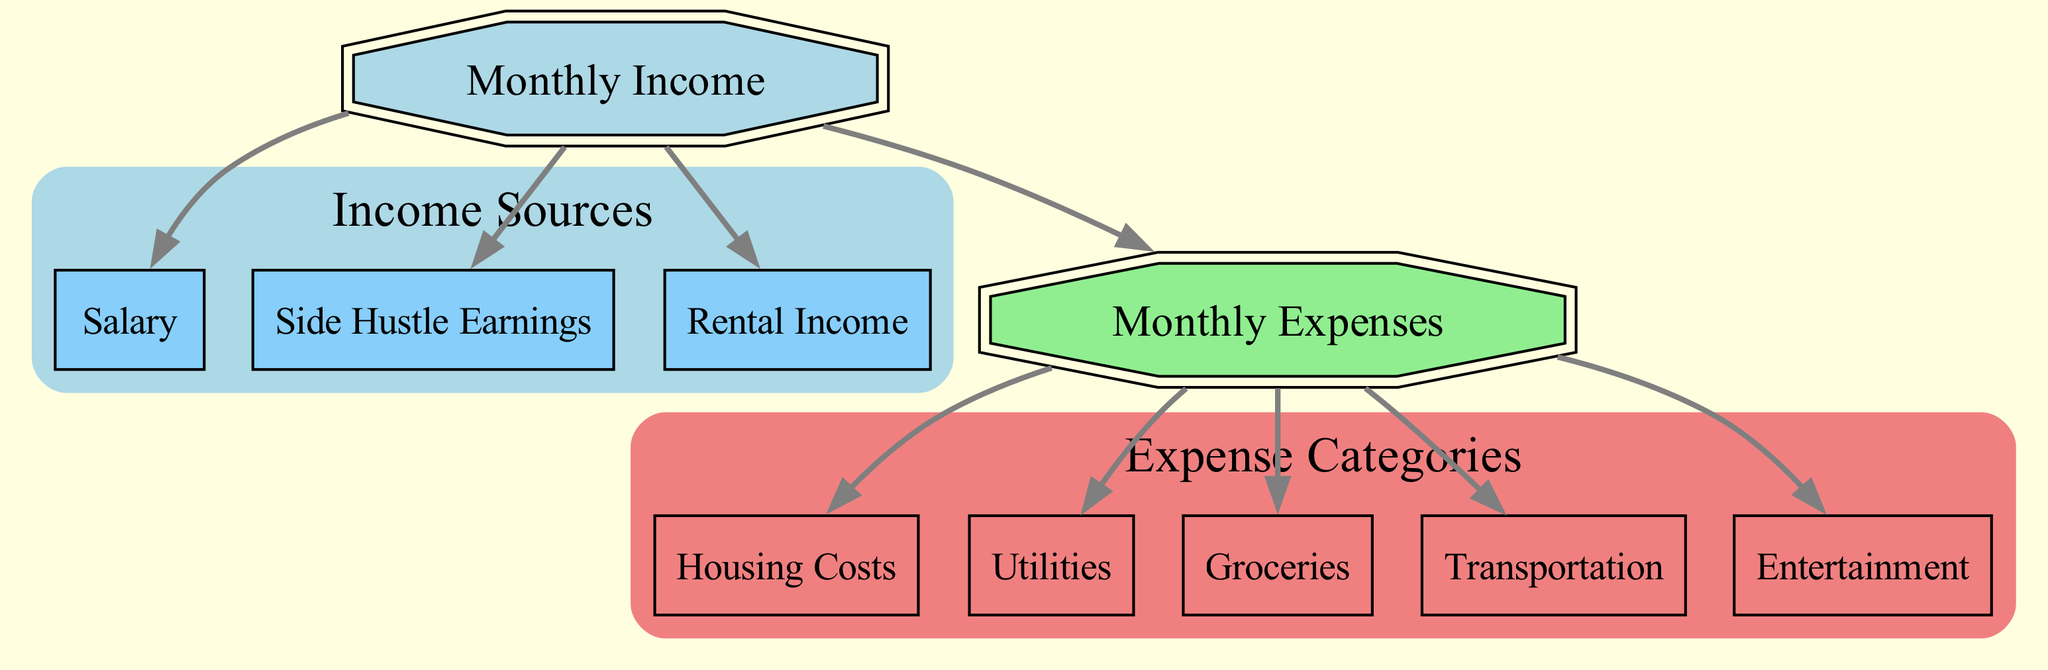What are the types of income sources in the diagram? The nodes labeled as Salary, Side Hustle Earnings, and Rental Income fall under the category of income sources in the diagram. These nodes are directly connected to the main Income node.
Answer: Salary, Side Hustle Earnings, Rental Income How many expense categories are shown in the diagram? The edges from the Expense node lead to five distinct categories: Housing Costs, Utilities, Groceries, Transportation, and Entertainment. Therefore, counting these nodes gives a total of five expense categories.
Answer: Five Which node is the primary source of income? The diagram shows the Income node at the top with nodes like Salary, Side Hustle, and Rental Income branching out from it. Hence, the primary source connecting to multiple income types is the Income node.
Answer: Income What is the relationship between Rental Income and Monthly Expenses? Rental Income is linked to the main Income node, which in turn connects to the Expense node representing Monthly Expenses. This indicates that Rental Income indirectly contributes to the Monthly Expenses through the Income node.
Answer: Contributes List the expense categories in the diagram. The expense categories are derived from the Expense node, which links to Housing Costs, Utilities, Groceries, Transportation, and Entertainment. Therefore, all these nodes function as expense categories.
Answer: Housing Costs, Utilities, Groceries, Transportation, Entertainment Which income source has the most direct impact on the Monthly Expenses? The diagram indicates that all income sources connect to the main Income node, which connects to Monthly Expenses. Therefore, no single source has a more direct impact, as they all contribute equally through the Income node.
Answer: None What type of node represents Monthly Income? The Monthly Income is categorized as a source node in the diagram, as depicted by its top-level position and its direct branching to other income types and expense categories.
Answer: Source How many edges connect to the Expense node? Analyzing the diagram, there are five edges leading from the Expense node to its related expense categories, indicating direct connections. Thus, the total count of edges related to the Expense node gives us five.
Answer: Five What is the purpose of the nodes labeled as 'expense'? The nodes labeled as 'expense' serve to categorize various monthly expenses. Each of these nodes is an important part of the overall Expense category, providing a clear breakdown of where money is allocated.
Answer: Categorization 